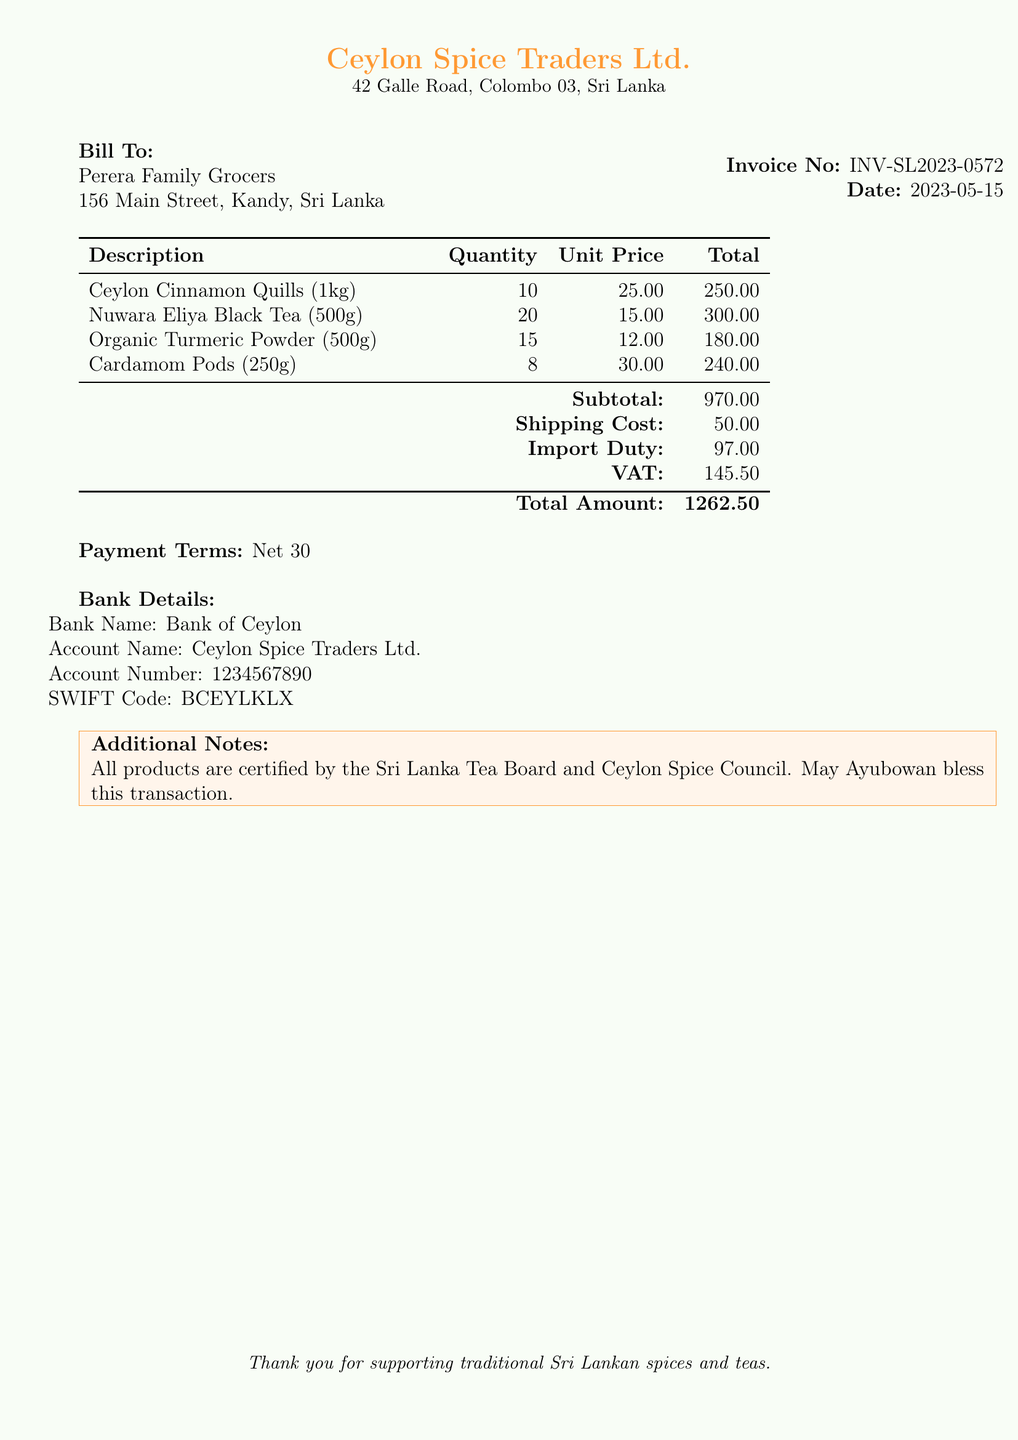What is the invoice number? The invoice number is listed prominently in the document to identify this specific transaction, which helps in record-keeping.
Answer: INV-SL2023-0572 What is the total amount due? The total amount is calculated by summing the subtotal, shipping cost, import duty, and VAT, which is clearly stated at the bottom of the table.
Answer: 1262.50 What is the shipping cost? The shipping cost is specified in the bill and represents the charge for transporting the goods.
Answer: 50.00 How much Ceylon Cinnamon Quills is ordered? The quantity of Ceylon Cinnamon Quills ordered can be found in the itemized section of the invoice.
Answer: 10 What are the payment terms? The payment terms are outlined in the document, indicating how long the buyer has to pay the invoice.
Answer: Net 30 What is the VAT amount? The VAT amount is included as part of the total calculations on the invoice, providing transparency on additional charges.
Answer: 145.50 What is the account number for payments? The account number is provided for customers to make bank transfers, ensuring the transaction process is clear.
Answer: 1234567890 What is the address of the supplier? The supplier's address is necessary for identification and correspondence related to the order.
Answer: 42 Galle Road, Colombo 03, Sri Lanka What type of products are listed in the invoice? The types of products reflect traditional items that are commonly associated with Sri Lankan culture and cuisine.
Answer: Authentic Sri Lankan spices and tea leaves 